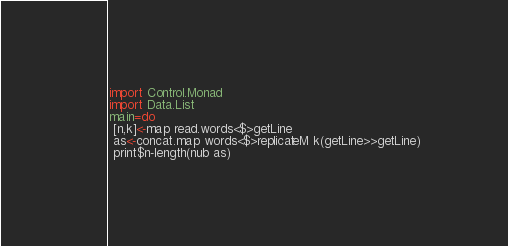Convert code to text. <code><loc_0><loc_0><loc_500><loc_500><_Haskell_>import Control.Monad
import Data.List
main=do
 [n,k]<-map read.words<$>getLine
 as<-concat.map words<$>replicateM k(getLine>>getLine)
 print$n-length(nub as)</code> 